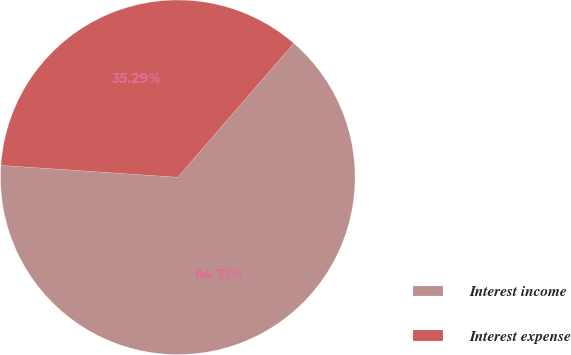Convert chart. <chart><loc_0><loc_0><loc_500><loc_500><pie_chart><fcel>Interest income<fcel>Interest expense<nl><fcel>64.71%<fcel>35.29%<nl></chart> 